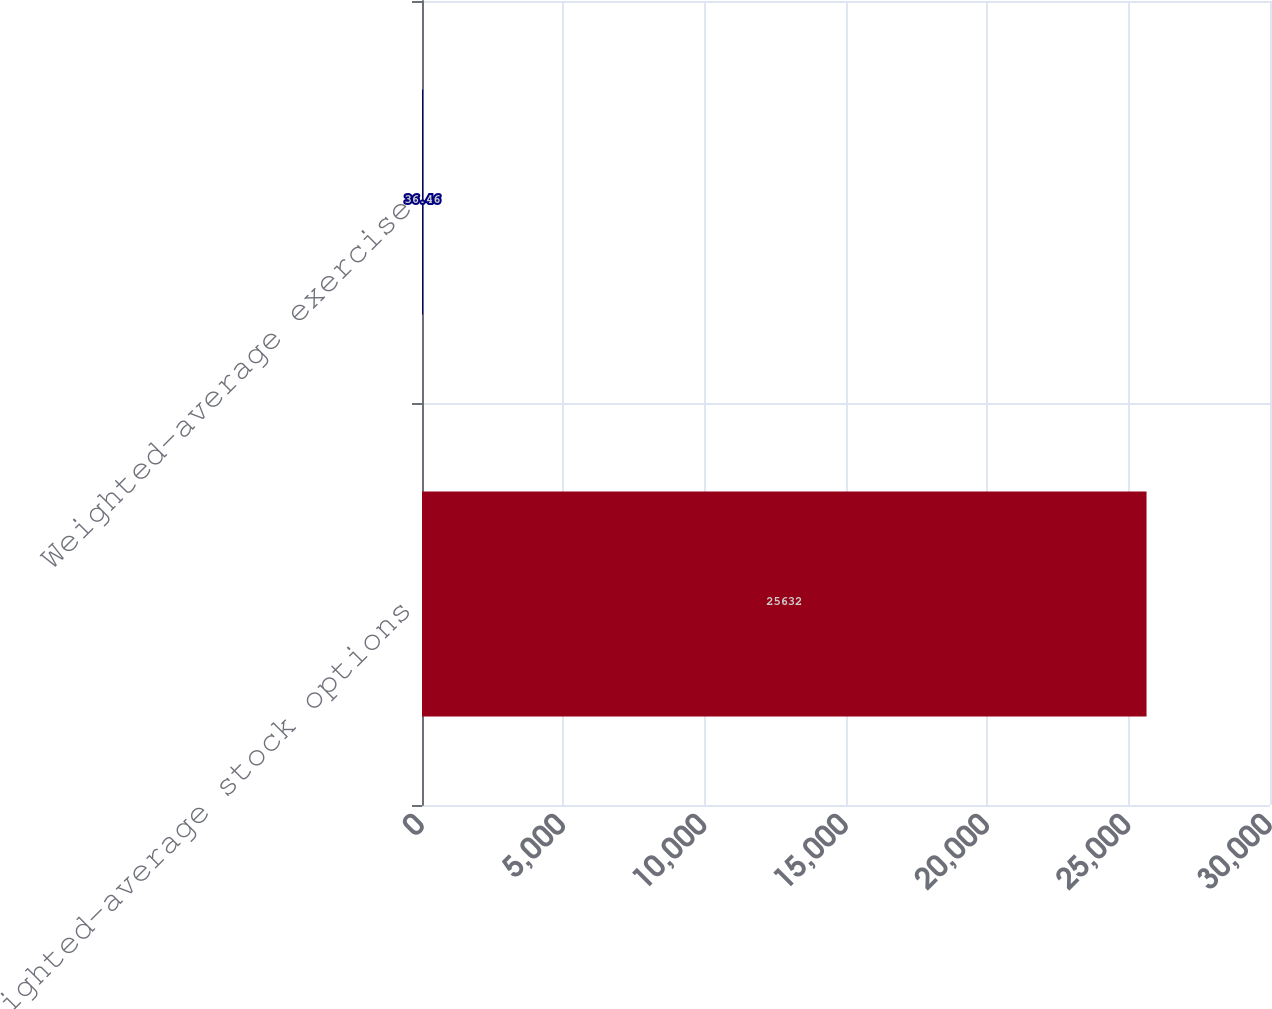Convert chart to OTSL. <chart><loc_0><loc_0><loc_500><loc_500><bar_chart><fcel>Weighted-average stock options<fcel>Weighted-average exercise<nl><fcel>25632<fcel>36.46<nl></chart> 